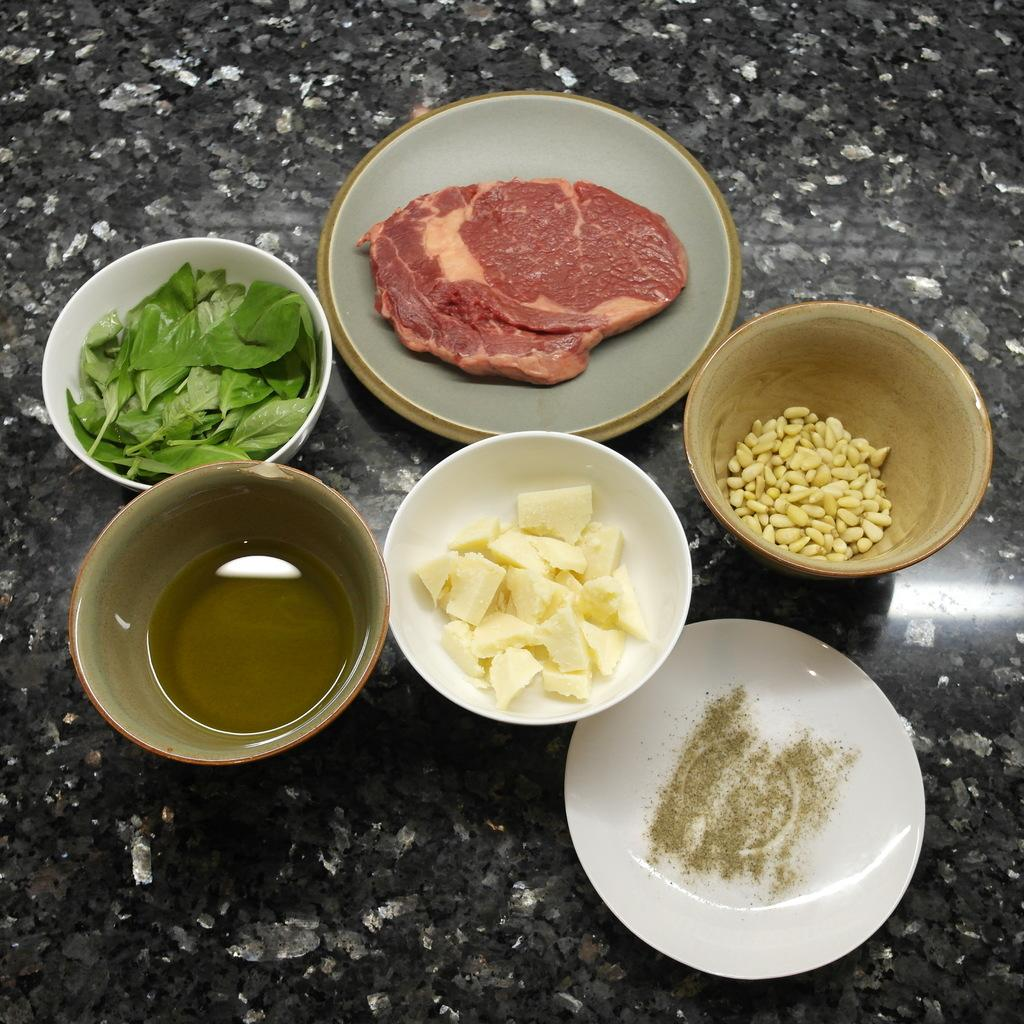What type of objects are present in the image? There are food items in the image. How are the food items arranged or contained? The food items are in bowls. What is the color of the surface beneath the bowls? The surface beneath the bowls is black and white in color. What type of letters can be seen in the image? There are no letters present in the image; it features food items in bowls on a black and white surface. 